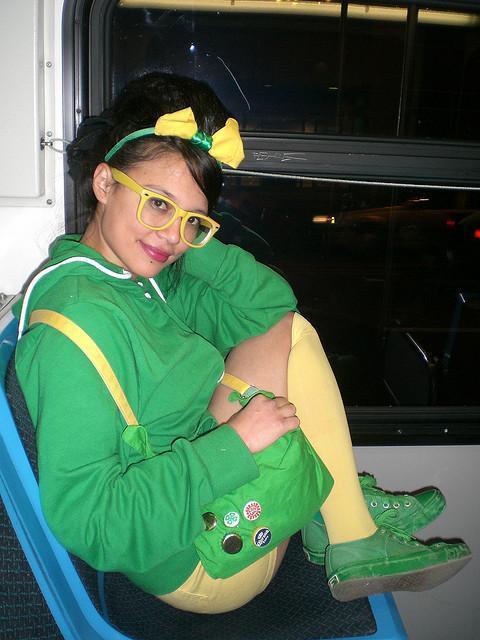How many badges are on her purse?
Give a very brief answer. 5. How many airplanes are flying to the left of the person?
Give a very brief answer. 0. 